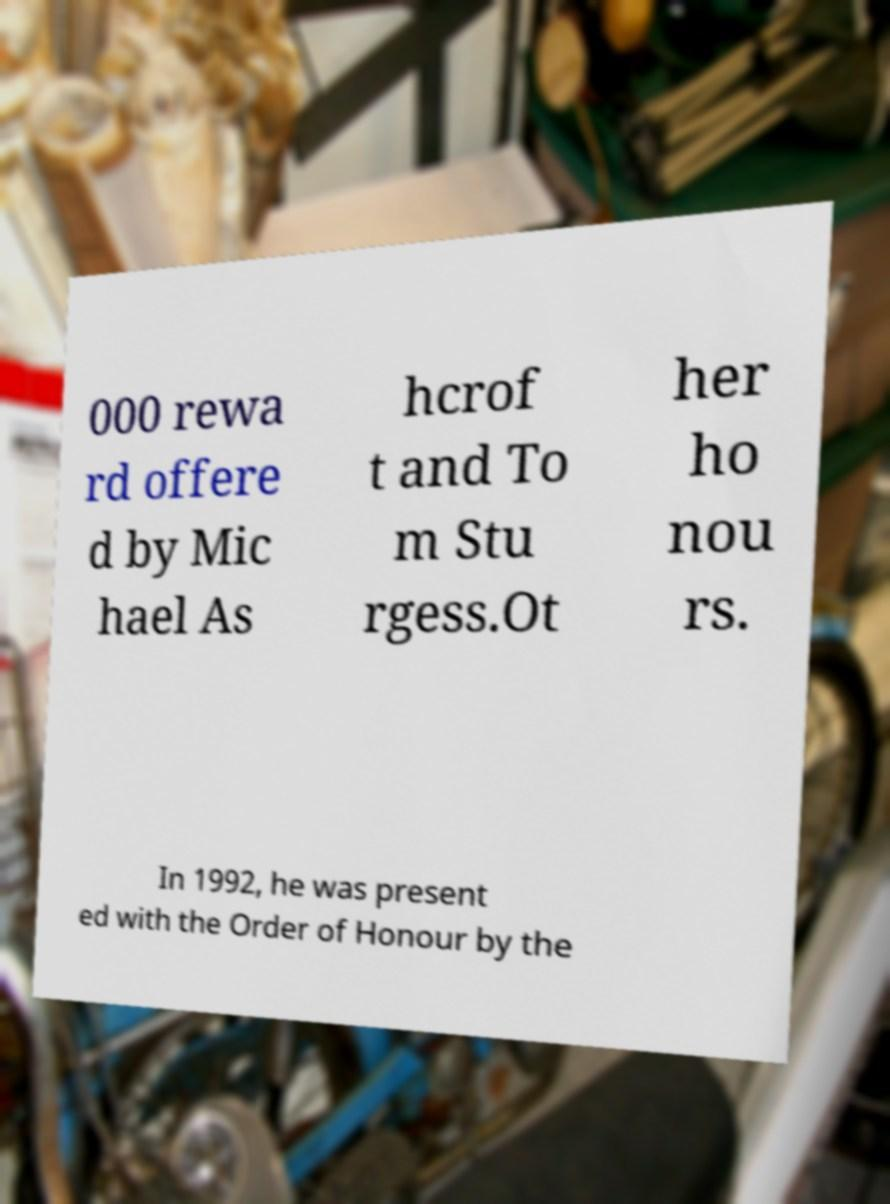Could you extract and type out the text from this image? 000 rewa rd offere d by Mic hael As hcrof t and To m Stu rgess.Ot her ho nou rs. In 1992, he was present ed with the Order of Honour by the 